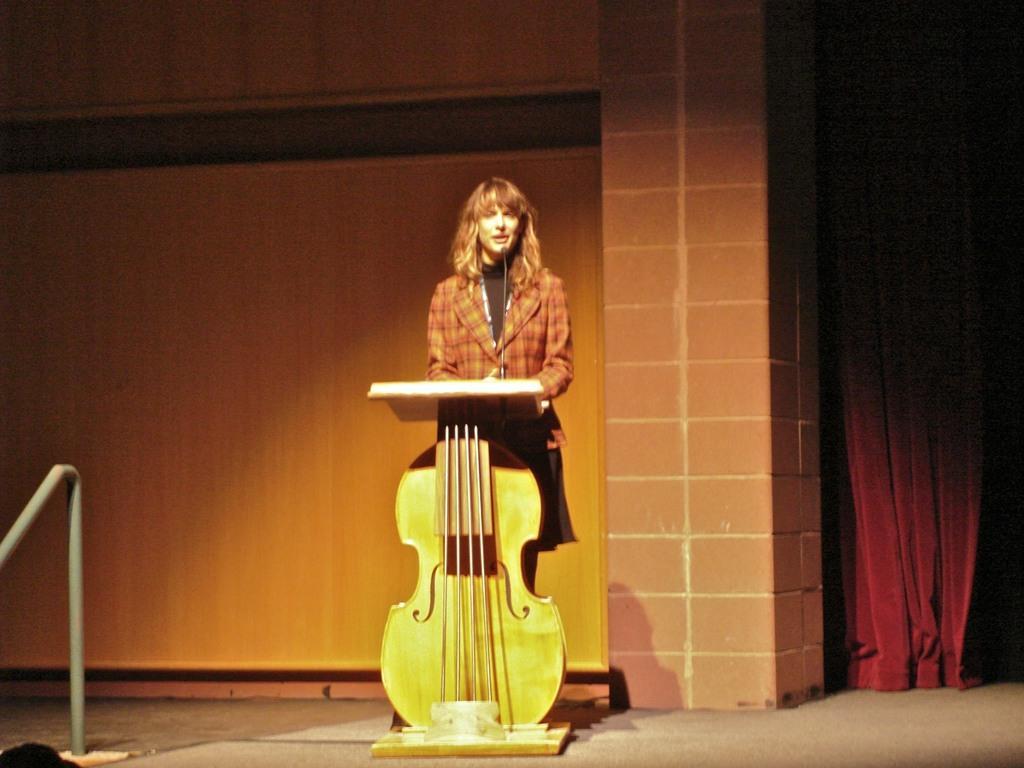How would you summarize this image in a sentence or two? This picture shows a woman, standing near a podium which is in the shape of a guitar. In the background, there is a wall and a red colored, curtain here. 